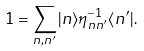Convert formula to latex. <formula><loc_0><loc_0><loc_500><loc_500>1 = \sum _ { n , n ^ { \prime } } | n \rangle \eta _ { n n ^ { \prime } } ^ { - 1 } \langle n ^ { \prime } | .</formula> 